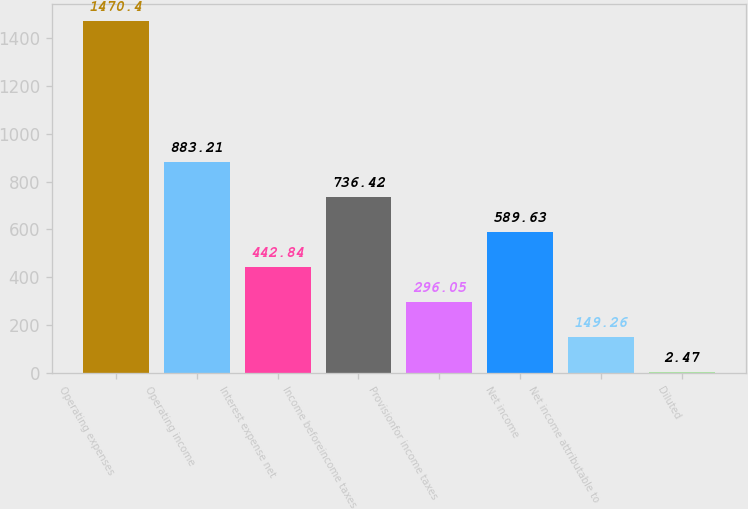Convert chart to OTSL. <chart><loc_0><loc_0><loc_500><loc_500><bar_chart><fcel>Operating expenses<fcel>Operating income<fcel>Interest expense net<fcel>Income beforeincome taxes<fcel>Provisionfor income taxes<fcel>Net income<fcel>Net income attributable to<fcel>Diluted<nl><fcel>1470.4<fcel>883.21<fcel>442.84<fcel>736.42<fcel>296.05<fcel>589.63<fcel>149.26<fcel>2.47<nl></chart> 